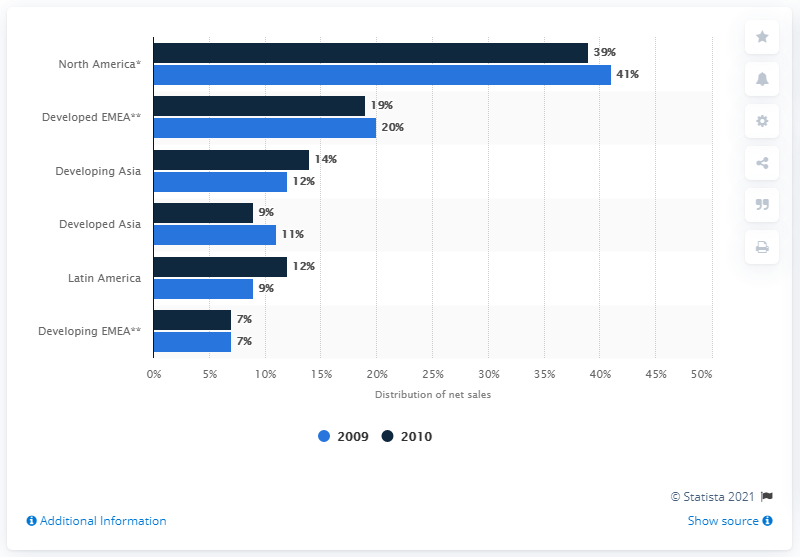Indicate a few pertinent items in this graphic. During the period between 2009 and 2010 in developing Asia, the ratio of greenhouse gas emissions per unit of GDP was 0.857142857, indicating a decrease in emissions per unit of economic activity compared to the previous year. The data indicates that North America has a category that shows 39 and 41 percentages. 